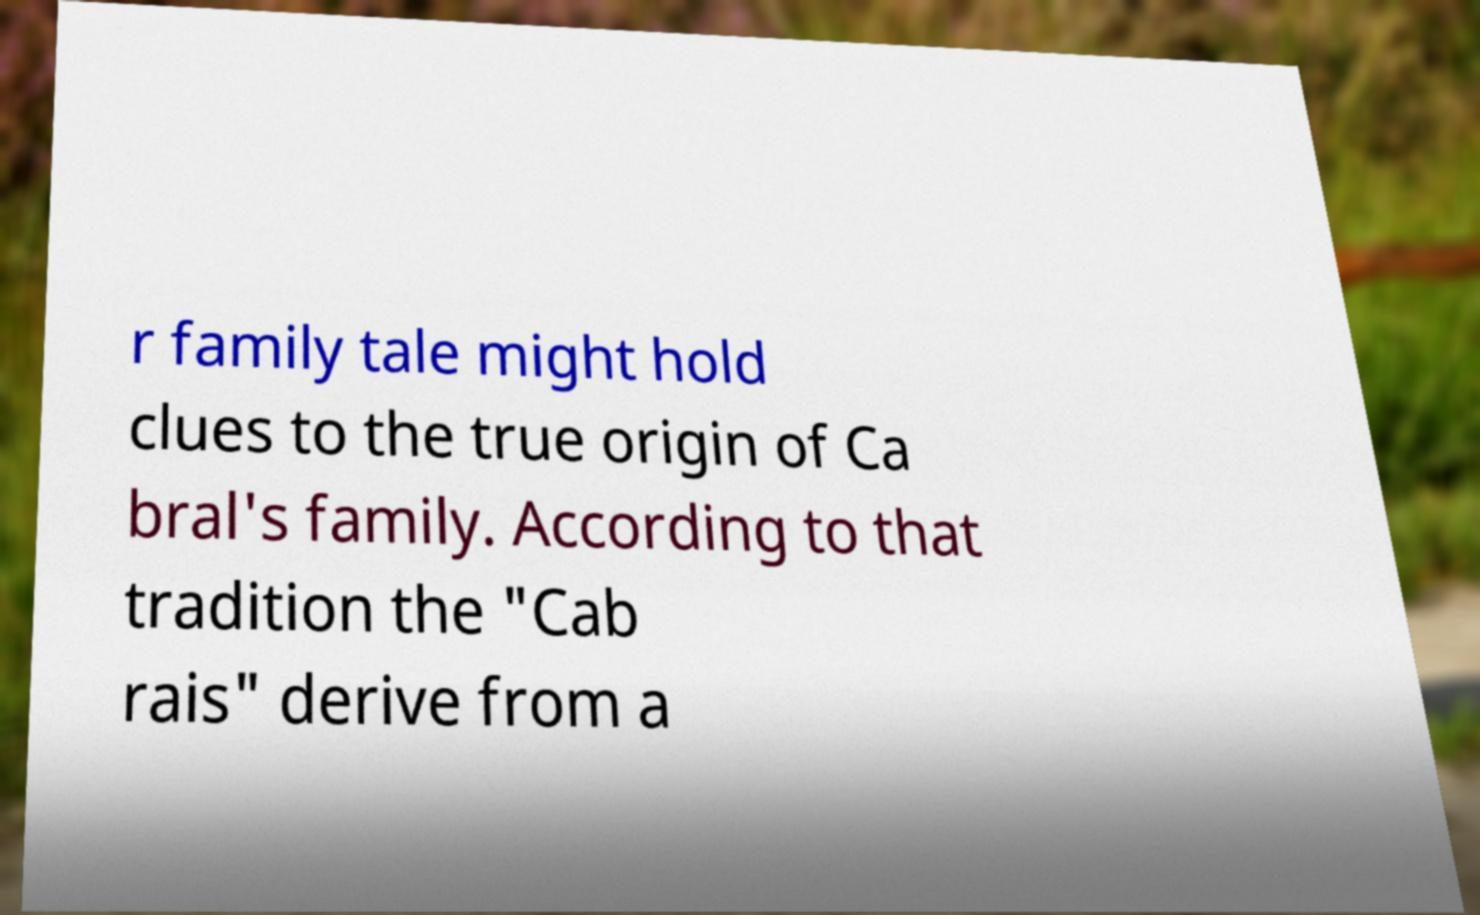I need the written content from this picture converted into text. Can you do that? r family tale might hold clues to the true origin of Ca bral's family. According to that tradition the "Cab rais" derive from a 